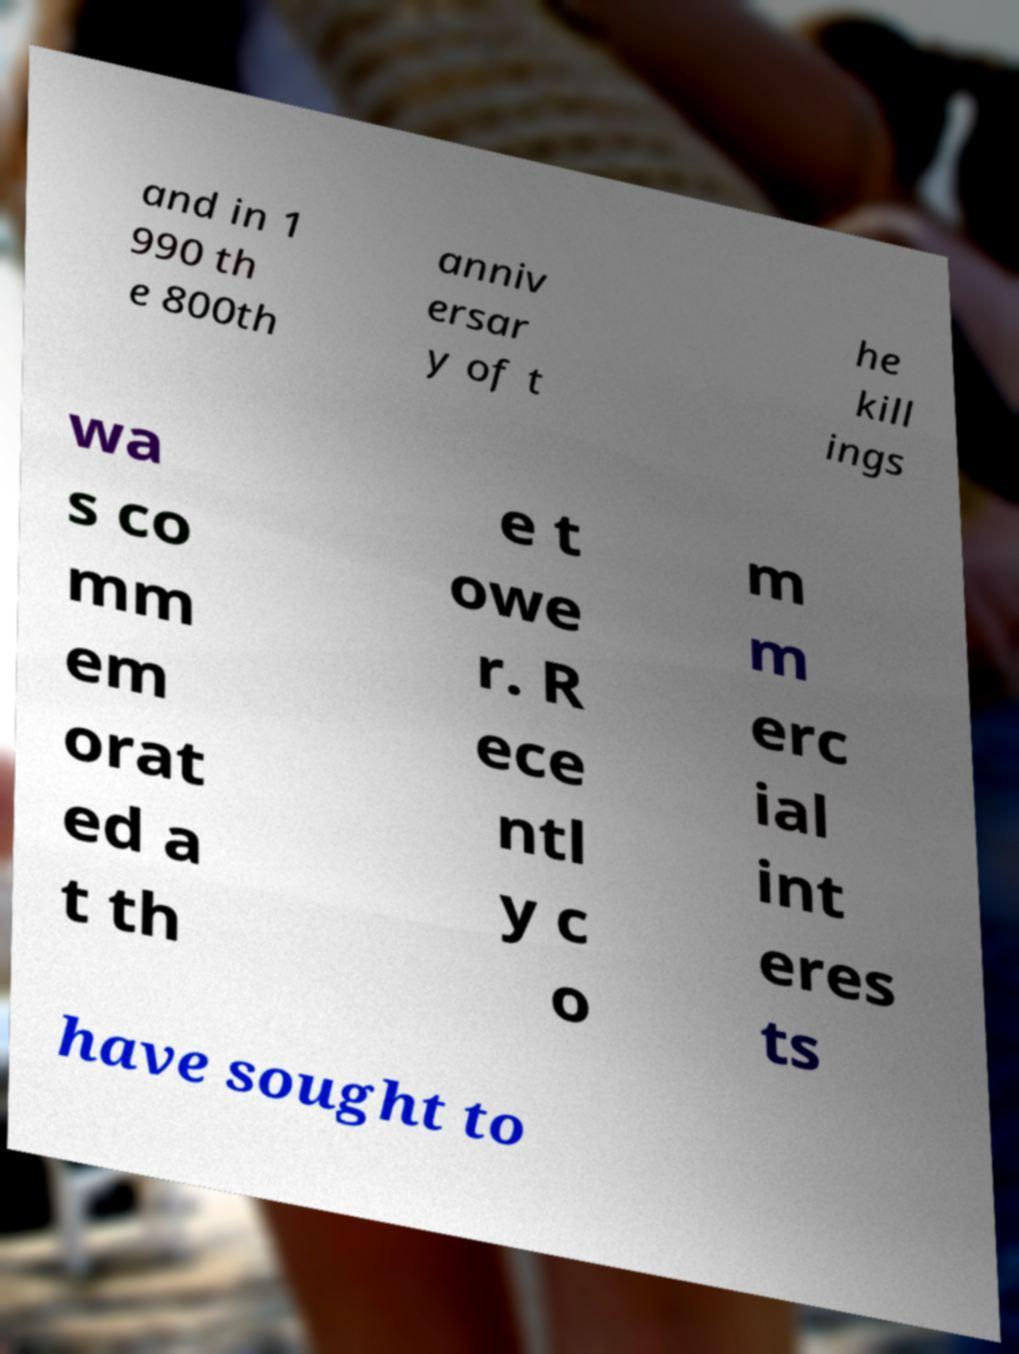There's text embedded in this image that I need extracted. Can you transcribe it verbatim? and in 1 990 th e 800th anniv ersar y of t he kill ings wa s co mm em orat ed a t th e t owe r. R ece ntl y c o m m erc ial int eres ts have sought to 